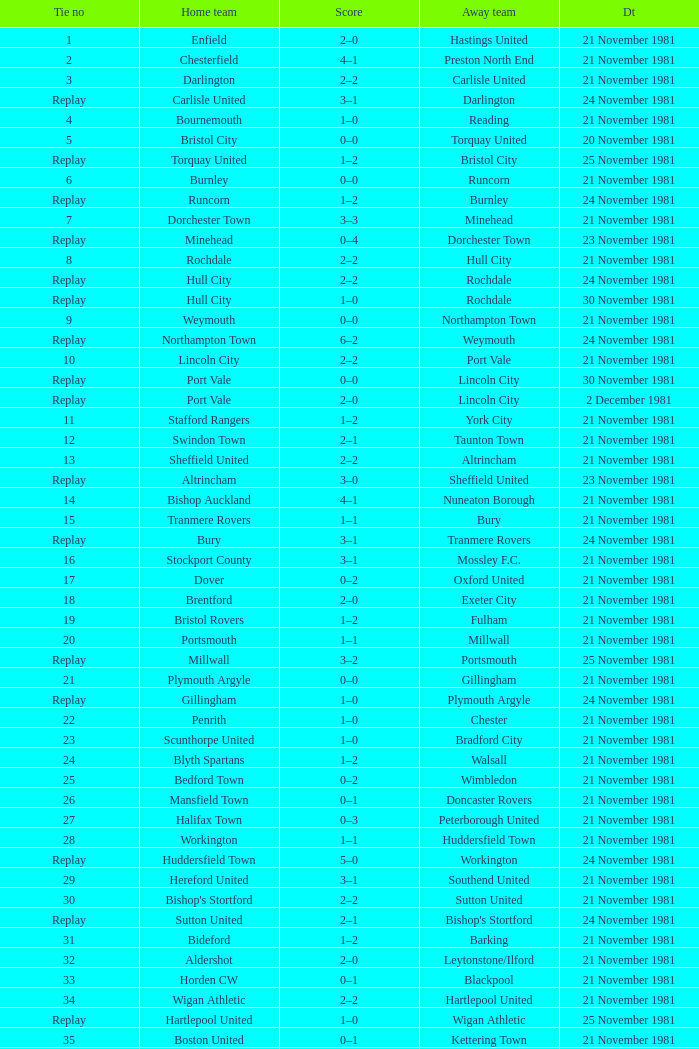On what date was tie number 4? 21 November 1981. 